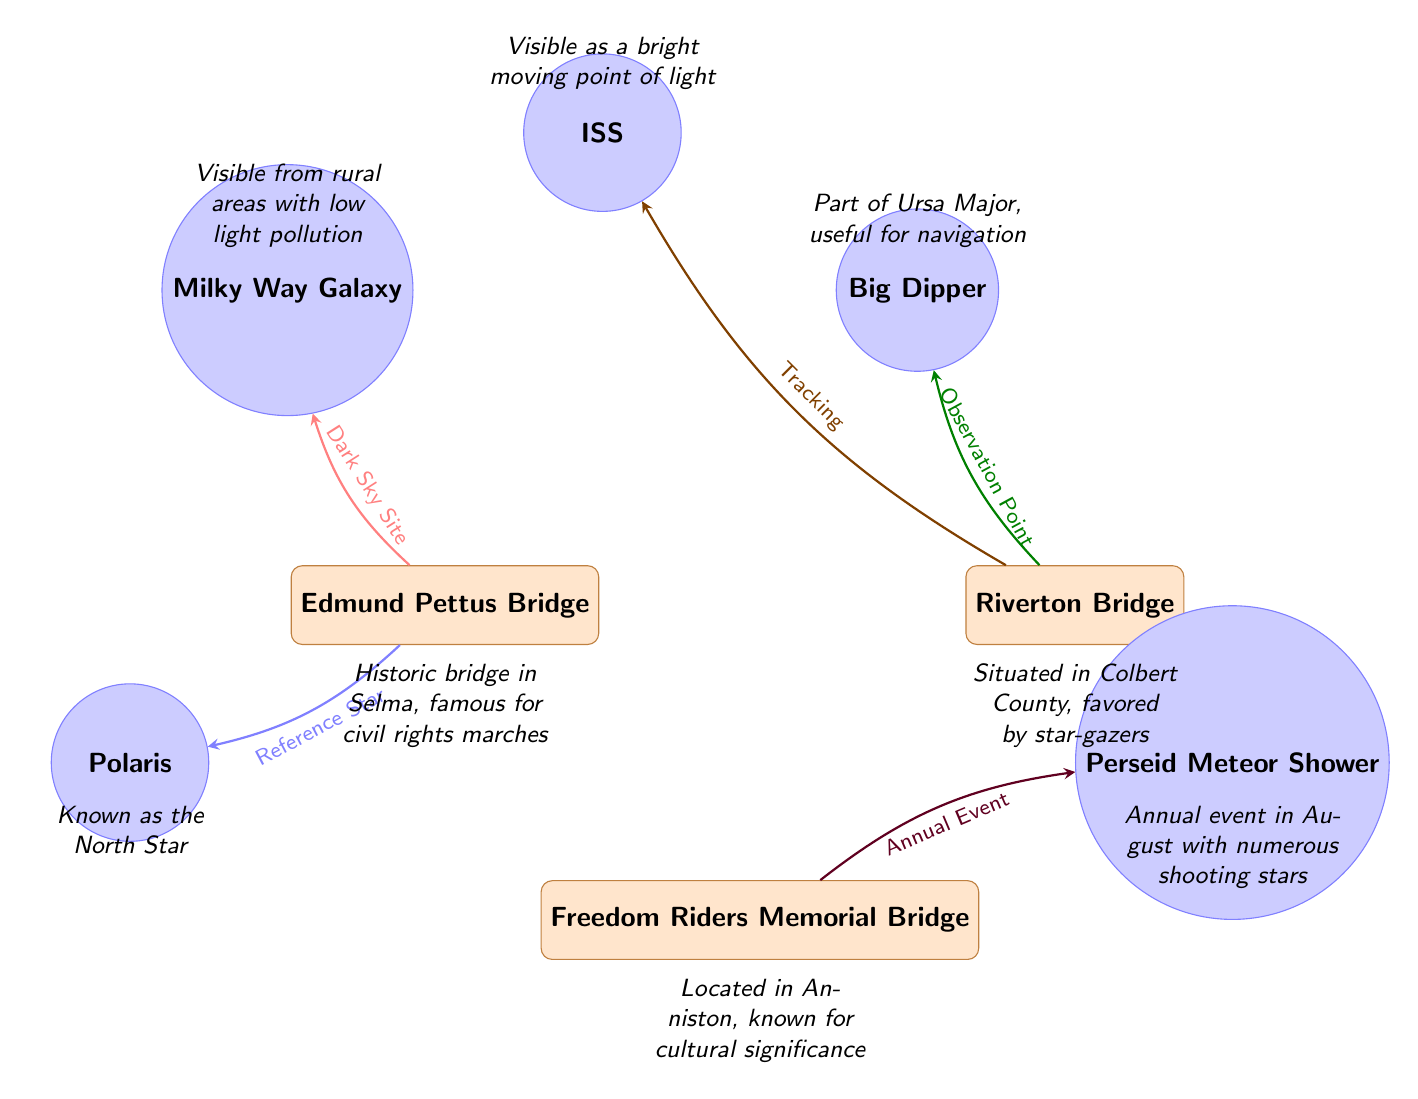What are the names of the bridges depicted in the diagram? The diagram includes three bridges named Edmund Pettus Bridge, Riverton Bridge, and Freedom Riders Memorial Bridge. This can be determined by looking at the labels on each bridge node represented in the diagram.
Answer: Edmund Pettus Bridge, Riverton Bridge, Freedom Riders Memorial Bridge Which celestial object is associated with the Edmund Pettus Bridge? The Edmund Pettus Bridge is connected to the Milky Way Galaxy, as indicated by the arrow directing from the bridge to this specific celestial object on the diagram.
Answer: Milky Way Galaxy How many celestial objects are represented in the diagram? The diagram shows a total of five celestial objects: Milky Way Galaxy, Big Dipper, Perseid Meteor Shower, Polaris, and ISS. This count can be verified by counting the celestial nodes in the diagram.
Answer: 5 What type of location is the Riverton Bridge noted for? The Riverton Bridge is described as an observation point, which is inferred from the arrow pointing from the bridge to the Big Dipper with the label indicating its use as a point for observing stars.
Answer: Observation Point How is the Freedom Riders Memorial Bridge connected to the Perseid Meteor Shower? The Freedom Riders Memorial Bridge is linked to the Perseid Meteor Shower through an annual event, as detailed by the arrow pointing from the bridge to the meteor shower with the corresponding label. This indicates that the bridge is known for events related to meteor viewing.
Answer: Annual Event What star is referenced as a reference point from the Edmund Pettus Bridge? The star connected to the Edmund Pettus Bridge as a reference point is Polaris, as shown by the arrow leading from the bridge node to Polaris with an identified label.
Answer: Polaris Which celestial object is visible from rural areas with low light pollution? The diagram indicates that the Milky Way Galaxy is visible from rural areas with low light pollution, as noted in the label above the Milky Way node.
Answer: Milky Way Galaxy What celestial object is represented as a bright moving point of light? The object described as a bright moving point of light is the ISS (International Space Station), as indicated by the label associated with the ISS node in the diagram.
Answer: ISS 